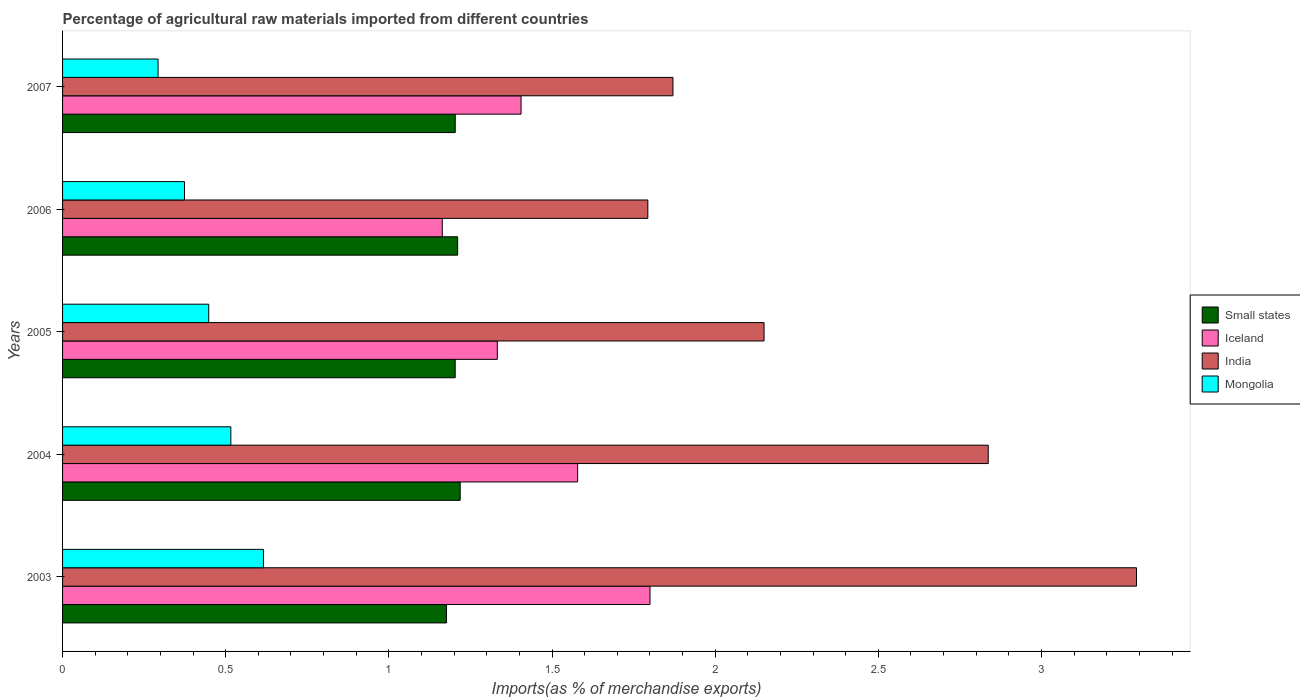How many different coloured bars are there?
Ensure brevity in your answer.  4. How many bars are there on the 5th tick from the bottom?
Your response must be concise. 4. What is the percentage of imports to different countries in Mongolia in 2004?
Give a very brief answer. 0.52. Across all years, what is the maximum percentage of imports to different countries in India?
Give a very brief answer. 3.29. Across all years, what is the minimum percentage of imports to different countries in Small states?
Offer a very short reply. 1.18. In which year was the percentage of imports to different countries in India minimum?
Make the answer very short. 2006. What is the total percentage of imports to different countries in India in the graph?
Offer a very short reply. 11.94. What is the difference between the percentage of imports to different countries in Small states in 2003 and that in 2004?
Ensure brevity in your answer.  -0.04. What is the difference between the percentage of imports to different countries in Small states in 2005 and the percentage of imports to different countries in India in 2003?
Offer a very short reply. -2.09. What is the average percentage of imports to different countries in Iceland per year?
Your response must be concise. 1.46. In the year 2006, what is the difference between the percentage of imports to different countries in Iceland and percentage of imports to different countries in India?
Provide a succinct answer. -0.63. What is the ratio of the percentage of imports to different countries in Small states in 2005 to that in 2006?
Ensure brevity in your answer.  0.99. What is the difference between the highest and the second highest percentage of imports to different countries in Mongolia?
Your answer should be compact. 0.1. What is the difference between the highest and the lowest percentage of imports to different countries in Small states?
Make the answer very short. 0.04. Is the sum of the percentage of imports to different countries in India in 2004 and 2007 greater than the maximum percentage of imports to different countries in Small states across all years?
Keep it short and to the point. Yes. Is it the case that in every year, the sum of the percentage of imports to different countries in Small states and percentage of imports to different countries in Iceland is greater than the sum of percentage of imports to different countries in India and percentage of imports to different countries in Mongolia?
Your answer should be compact. No. Is it the case that in every year, the sum of the percentage of imports to different countries in Mongolia and percentage of imports to different countries in Iceland is greater than the percentage of imports to different countries in Small states?
Your response must be concise. Yes. How many bars are there?
Offer a very short reply. 20. Are the values on the major ticks of X-axis written in scientific E-notation?
Make the answer very short. No. Does the graph contain any zero values?
Provide a short and direct response. No. Does the graph contain grids?
Provide a short and direct response. No. Where does the legend appear in the graph?
Ensure brevity in your answer.  Center right. What is the title of the graph?
Provide a succinct answer. Percentage of agricultural raw materials imported from different countries. Does "Sudan" appear as one of the legend labels in the graph?
Make the answer very short. No. What is the label or title of the X-axis?
Your answer should be compact. Imports(as % of merchandise exports). What is the label or title of the Y-axis?
Offer a very short reply. Years. What is the Imports(as % of merchandise exports) of Small states in 2003?
Provide a succinct answer. 1.18. What is the Imports(as % of merchandise exports) of Iceland in 2003?
Your answer should be compact. 1.8. What is the Imports(as % of merchandise exports) in India in 2003?
Your answer should be very brief. 3.29. What is the Imports(as % of merchandise exports) of Mongolia in 2003?
Your answer should be very brief. 0.62. What is the Imports(as % of merchandise exports) of Small states in 2004?
Ensure brevity in your answer.  1.22. What is the Imports(as % of merchandise exports) in Iceland in 2004?
Make the answer very short. 1.58. What is the Imports(as % of merchandise exports) of India in 2004?
Your answer should be very brief. 2.84. What is the Imports(as % of merchandise exports) of Mongolia in 2004?
Provide a succinct answer. 0.52. What is the Imports(as % of merchandise exports) in Small states in 2005?
Your answer should be very brief. 1.2. What is the Imports(as % of merchandise exports) of Iceland in 2005?
Offer a very short reply. 1.33. What is the Imports(as % of merchandise exports) in India in 2005?
Your answer should be compact. 2.15. What is the Imports(as % of merchandise exports) of Mongolia in 2005?
Ensure brevity in your answer.  0.45. What is the Imports(as % of merchandise exports) of Small states in 2006?
Give a very brief answer. 1.21. What is the Imports(as % of merchandise exports) in Iceland in 2006?
Ensure brevity in your answer.  1.16. What is the Imports(as % of merchandise exports) of India in 2006?
Your response must be concise. 1.79. What is the Imports(as % of merchandise exports) in Mongolia in 2006?
Keep it short and to the point. 0.37. What is the Imports(as % of merchandise exports) of Small states in 2007?
Provide a succinct answer. 1.2. What is the Imports(as % of merchandise exports) of Iceland in 2007?
Provide a succinct answer. 1.41. What is the Imports(as % of merchandise exports) in India in 2007?
Your answer should be compact. 1.87. What is the Imports(as % of merchandise exports) in Mongolia in 2007?
Give a very brief answer. 0.29. Across all years, what is the maximum Imports(as % of merchandise exports) of Small states?
Ensure brevity in your answer.  1.22. Across all years, what is the maximum Imports(as % of merchandise exports) in Iceland?
Provide a succinct answer. 1.8. Across all years, what is the maximum Imports(as % of merchandise exports) in India?
Give a very brief answer. 3.29. Across all years, what is the maximum Imports(as % of merchandise exports) in Mongolia?
Give a very brief answer. 0.62. Across all years, what is the minimum Imports(as % of merchandise exports) in Small states?
Your response must be concise. 1.18. Across all years, what is the minimum Imports(as % of merchandise exports) of Iceland?
Your answer should be very brief. 1.16. Across all years, what is the minimum Imports(as % of merchandise exports) of India?
Give a very brief answer. 1.79. Across all years, what is the minimum Imports(as % of merchandise exports) in Mongolia?
Keep it short and to the point. 0.29. What is the total Imports(as % of merchandise exports) of Small states in the graph?
Your answer should be very brief. 6.01. What is the total Imports(as % of merchandise exports) in Iceland in the graph?
Provide a succinct answer. 7.28. What is the total Imports(as % of merchandise exports) of India in the graph?
Offer a very short reply. 11.94. What is the total Imports(as % of merchandise exports) of Mongolia in the graph?
Offer a very short reply. 2.25. What is the difference between the Imports(as % of merchandise exports) of Small states in 2003 and that in 2004?
Offer a very short reply. -0.04. What is the difference between the Imports(as % of merchandise exports) of Iceland in 2003 and that in 2004?
Keep it short and to the point. 0.22. What is the difference between the Imports(as % of merchandise exports) in India in 2003 and that in 2004?
Provide a short and direct response. 0.45. What is the difference between the Imports(as % of merchandise exports) of Mongolia in 2003 and that in 2004?
Make the answer very short. 0.1. What is the difference between the Imports(as % of merchandise exports) of Small states in 2003 and that in 2005?
Keep it short and to the point. -0.03. What is the difference between the Imports(as % of merchandise exports) in Iceland in 2003 and that in 2005?
Your answer should be compact. 0.47. What is the difference between the Imports(as % of merchandise exports) of India in 2003 and that in 2005?
Offer a terse response. 1.14. What is the difference between the Imports(as % of merchandise exports) of Mongolia in 2003 and that in 2005?
Provide a short and direct response. 0.17. What is the difference between the Imports(as % of merchandise exports) in Small states in 2003 and that in 2006?
Offer a terse response. -0.03. What is the difference between the Imports(as % of merchandise exports) in Iceland in 2003 and that in 2006?
Offer a very short reply. 0.64. What is the difference between the Imports(as % of merchandise exports) in India in 2003 and that in 2006?
Your answer should be very brief. 1.5. What is the difference between the Imports(as % of merchandise exports) in Mongolia in 2003 and that in 2006?
Your response must be concise. 0.24. What is the difference between the Imports(as % of merchandise exports) of Small states in 2003 and that in 2007?
Your response must be concise. -0.03. What is the difference between the Imports(as % of merchandise exports) in Iceland in 2003 and that in 2007?
Give a very brief answer. 0.4. What is the difference between the Imports(as % of merchandise exports) of India in 2003 and that in 2007?
Give a very brief answer. 1.42. What is the difference between the Imports(as % of merchandise exports) in Mongolia in 2003 and that in 2007?
Provide a succinct answer. 0.32. What is the difference between the Imports(as % of merchandise exports) in Small states in 2004 and that in 2005?
Your answer should be compact. 0.02. What is the difference between the Imports(as % of merchandise exports) of Iceland in 2004 and that in 2005?
Offer a very short reply. 0.25. What is the difference between the Imports(as % of merchandise exports) of India in 2004 and that in 2005?
Your answer should be very brief. 0.69. What is the difference between the Imports(as % of merchandise exports) in Mongolia in 2004 and that in 2005?
Give a very brief answer. 0.07. What is the difference between the Imports(as % of merchandise exports) of Small states in 2004 and that in 2006?
Keep it short and to the point. 0.01. What is the difference between the Imports(as % of merchandise exports) of Iceland in 2004 and that in 2006?
Your response must be concise. 0.41. What is the difference between the Imports(as % of merchandise exports) of India in 2004 and that in 2006?
Offer a terse response. 1.04. What is the difference between the Imports(as % of merchandise exports) of Mongolia in 2004 and that in 2006?
Offer a very short reply. 0.14. What is the difference between the Imports(as % of merchandise exports) in Small states in 2004 and that in 2007?
Offer a terse response. 0.02. What is the difference between the Imports(as % of merchandise exports) of Iceland in 2004 and that in 2007?
Offer a very short reply. 0.17. What is the difference between the Imports(as % of merchandise exports) in India in 2004 and that in 2007?
Your answer should be very brief. 0.97. What is the difference between the Imports(as % of merchandise exports) in Mongolia in 2004 and that in 2007?
Give a very brief answer. 0.22. What is the difference between the Imports(as % of merchandise exports) in Small states in 2005 and that in 2006?
Offer a terse response. -0.01. What is the difference between the Imports(as % of merchandise exports) of Iceland in 2005 and that in 2006?
Provide a succinct answer. 0.17. What is the difference between the Imports(as % of merchandise exports) in India in 2005 and that in 2006?
Provide a short and direct response. 0.36. What is the difference between the Imports(as % of merchandise exports) of Mongolia in 2005 and that in 2006?
Ensure brevity in your answer.  0.07. What is the difference between the Imports(as % of merchandise exports) in Small states in 2005 and that in 2007?
Your response must be concise. -0. What is the difference between the Imports(as % of merchandise exports) of Iceland in 2005 and that in 2007?
Provide a short and direct response. -0.07. What is the difference between the Imports(as % of merchandise exports) of India in 2005 and that in 2007?
Offer a terse response. 0.28. What is the difference between the Imports(as % of merchandise exports) in Mongolia in 2005 and that in 2007?
Ensure brevity in your answer.  0.16. What is the difference between the Imports(as % of merchandise exports) of Small states in 2006 and that in 2007?
Provide a short and direct response. 0.01. What is the difference between the Imports(as % of merchandise exports) of Iceland in 2006 and that in 2007?
Your answer should be compact. -0.24. What is the difference between the Imports(as % of merchandise exports) of India in 2006 and that in 2007?
Provide a short and direct response. -0.08. What is the difference between the Imports(as % of merchandise exports) in Mongolia in 2006 and that in 2007?
Your answer should be very brief. 0.08. What is the difference between the Imports(as % of merchandise exports) of Small states in 2003 and the Imports(as % of merchandise exports) of Iceland in 2004?
Keep it short and to the point. -0.4. What is the difference between the Imports(as % of merchandise exports) of Small states in 2003 and the Imports(as % of merchandise exports) of India in 2004?
Offer a very short reply. -1.66. What is the difference between the Imports(as % of merchandise exports) in Small states in 2003 and the Imports(as % of merchandise exports) in Mongolia in 2004?
Offer a terse response. 0.66. What is the difference between the Imports(as % of merchandise exports) in Iceland in 2003 and the Imports(as % of merchandise exports) in India in 2004?
Provide a short and direct response. -1.04. What is the difference between the Imports(as % of merchandise exports) in Iceland in 2003 and the Imports(as % of merchandise exports) in Mongolia in 2004?
Offer a terse response. 1.28. What is the difference between the Imports(as % of merchandise exports) of India in 2003 and the Imports(as % of merchandise exports) of Mongolia in 2004?
Your answer should be compact. 2.78. What is the difference between the Imports(as % of merchandise exports) in Small states in 2003 and the Imports(as % of merchandise exports) in Iceland in 2005?
Your answer should be very brief. -0.16. What is the difference between the Imports(as % of merchandise exports) of Small states in 2003 and the Imports(as % of merchandise exports) of India in 2005?
Give a very brief answer. -0.97. What is the difference between the Imports(as % of merchandise exports) in Small states in 2003 and the Imports(as % of merchandise exports) in Mongolia in 2005?
Ensure brevity in your answer.  0.73. What is the difference between the Imports(as % of merchandise exports) of Iceland in 2003 and the Imports(as % of merchandise exports) of India in 2005?
Your answer should be very brief. -0.35. What is the difference between the Imports(as % of merchandise exports) of Iceland in 2003 and the Imports(as % of merchandise exports) of Mongolia in 2005?
Provide a succinct answer. 1.35. What is the difference between the Imports(as % of merchandise exports) in India in 2003 and the Imports(as % of merchandise exports) in Mongolia in 2005?
Ensure brevity in your answer.  2.84. What is the difference between the Imports(as % of merchandise exports) of Small states in 2003 and the Imports(as % of merchandise exports) of Iceland in 2006?
Ensure brevity in your answer.  0.01. What is the difference between the Imports(as % of merchandise exports) of Small states in 2003 and the Imports(as % of merchandise exports) of India in 2006?
Offer a terse response. -0.62. What is the difference between the Imports(as % of merchandise exports) in Small states in 2003 and the Imports(as % of merchandise exports) in Mongolia in 2006?
Your answer should be very brief. 0.8. What is the difference between the Imports(as % of merchandise exports) in Iceland in 2003 and the Imports(as % of merchandise exports) in India in 2006?
Provide a succinct answer. 0.01. What is the difference between the Imports(as % of merchandise exports) in Iceland in 2003 and the Imports(as % of merchandise exports) in Mongolia in 2006?
Keep it short and to the point. 1.43. What is the difference between the Imports(as % of merchandise exports) in India in 2003 and the Imports(as % of merchandise exports) in Mongolia in 2006?
Provide a succinct answer. 2.92. What is the difference between the Imports(as % of merchandise exports) in Small states in 2003 and the Imports(as % of merchandise exports) in Iceland in 2007?
Your response must be concise. -0.23. What is the difference between the Imports(as % of merchandise exports) of Small states in 2003 and the Imports(as % of merchandise exports) of India in 2007?
Keep it short and to the point. -0.69. What is the difference between the Imports(as % of merchandise exports) in Small states in 2003 and the Imports(as % of merchandise exports) in Mongolia in 2007?
Offer a very short reply. 0.88. What is the difference between the Imports(as % of merchandise exports) in Iceland in 2003 and the Imports(as % of merchandise exports) in India in 2007?
Your answer should be compact. -0.07. What is the difference between the Imports(as % of merchandise exports) in Iceland in 2003 and the Imports(as % of merchandise exports) in Mongolia in 2007?
Offer a terse response. 1.51. What is the difference between the Imports(as % of merchandise exports) of India in 2003 and the Imports(as % of merchandise exports) of Mongolia in 2007?
Your answer should be very brief. 3. What is the difference between the Imports(as % of merchandise exports) of Small states in 2004 and the Imports(as % of merchandise exports) of Iceland in 2005?
Offer a terse response. -0.11. What is the difference between the Imports(as % of merchandise exports) of Small states in 2004 and the Imports(as % of merchandise exports) of India in 2005?
Provide a succinct answer. -0.93. What is the difference between the Imports(as % of merchandise exports) in Small states in 2004 and the Imports(as % of merchandise exports) in Mongolia in 2005?
Make the answer very short. 0.77. What is the difference between the Imports(as % of merchandise exports) of Iceland in 2004 and the Imports(as % of merchandise exports) of India in 2005?
Offer a terse response. -0.57. What is the difference between the Imports(as % of merchandise exports) in Iceland in 2004 and the Imports(as % of merchandise exports) in Mongolia in 2005?
Offer a terse response. 1.13. What is the difference between the Imports(as % of merchandise exports) in India in 2004 and the Imports(as % of merchandise exports) in Mongolia in 2005?
Provide a succinct answer. 2.39. What is the difference between the Imports(as % of merchandise exports) of Small states in 2004 and the Imports(as % of merchandise exports) of Iceland in 2006?
Ensure brevity in your answer.  0.05. What is the difference between the Imports(as % of merchandise exports) in Small states in 2004 and the Imports(as % of merchandise exports) in India in 2006?
Ensure brevity in your answer.  -0.57. What is the difference between the Imports(as % of merchandise exports) in Small states in 2004 and the Imports(as % of merchandise exports) in Mongolia in 2006?
Keep it short and to the point. 0.84. What is the difference between the Imports(as % of merchandise exports) of Iceland in 2004 and the Imports(as % of merchandise exports) of India in 2006?
Provide a succinct answer. -0.22. What is the difference between the Imports(as % of merchandise exports) in Iceland in 2004 and the Imports(as % of merchandise exports) in Mongolia in 2006?
Provide a short and direct response. 1.2. What is the difference between the Imports(as % of merchandise exports) in India in 2004 and the Imports(as % of merchandise exports) in Mongolia in 2006?
Ensure brevity in your answer.  2.46. What is the difference between the Imports(as % of merchandise exports) of Small states in 2004 and the Imports(as % of merchandise exports) of Iceland in 2007?
Give a very brief answer. -0.19. What is the difference between the Imports(as % of merchandise exports) in Small states in 2004 and the Imports(as % of merchandise exports) in India in 2007?
Your response must be concise. -0.65. What is the difference between the Imports(as % of merchandise exports) in Small states in 2004 and the Imports(as % of merchandise exports) in Mongolia in 2007?
Your response must be concise. 0.93. What is the difference between the Imports(as % of merchandise exports) of Iceland in 2004 and the Imports(as % of merchandise exports) of India in 2007?
Offer a terse response. -0.29. What is the difference between the Imports(as % of merchandise exports) of Iceland in 2004 and the Imports(as % of merchandise exports) of Mongolia in 2007?
Provide a succinct answer. 1.29. What is the difference between the Imports(as % of merchandise exports) in India in 2004 and the Imports(as % of merchandise exports) in Mongolia in 2007?
Your answer should be compact. 2.54. What is the difference between the Imports(as % of merchandise exports) of Small states in 2005 and the Imports(as % of merchandise exports) of Iceland in 2006?
Offer a very short reply. 0.04. What is the difference between the Imports(as % of merchandise exports) in Small states in 2005 and the Imports(as % of merchandise exports) in India in 2006?
Make the answer very short. -0.59. What is the difference between the Imports(as % of merchandise exports) of Small states in 2005 and the Imports(as % of merchandise exports) of Mongolia in 2006?
Provide a succinct answer. 0.83. What is the difference between the Imports(as % of merchandise exports) of Iceland in 2005 and the Imports(as % of merchandise exports) of India in 2006?
Provide a succinct answer. -0.46. What is the difference between the Imports(as % of merchandise exports) of Iceland in 2005 and the Imports(as % of merchandise exports) of Mongolia in 2006?
Provide a short and direct response. 0.96. What is the difference between the Imports(as % of merchandise exports) of India in 2005 and the Imports(as % of merchandise exports) of Mongolia in 2006?
Give a very brief answer. 1.78. What is the difference between the Imports(as % of merchandise exports) in Small states in 2005 and the Imports(as % of merchandise exports) in Iceland in 2007?
Offer a terse response. -0.2. What is the difference between the Imports(as % of merchandise exports) in Small states in 2005 and the Imports(as % of merchandise exports) in India in 2007?
Your answer should be very brief. -0.67. What is the difference between the Imports(as % of merchandise exports) in Small states in 2005 and the Imports(as % of merchandise exports) in Mongolia in 2007?
Offer a very short reply. 0.91. What is the difference between the Imports(as % of merchandise exports) of Iceland in 2005 and the Imports(as % of merchandise exports) of India in 2007?
Provide a short and direct response. -0.54. What is the difference between the Imports(as % of merchandise exports) of Iceland in 2005 and the Imports(as % of merchandise exports) of Mongolia in 2007?
Offer a terse response. 1.04. What is the difference between the Imports(as % of merchandise exports) in India in 2005 and the Imports(as % of merchandise exports) in Mongolia in 2007?
Give a very brief answer. 1.86. What is the difference between the Imports(as % of merchandise exports) in Small states in 2006 and the Imports(as % of merchandise exports) in Iceland in 2007?
Your response must be concise. -0.19. What is the difference between the Imports(as % of merchandise exports) of Small states in 2006 and the Imports(as % of merchandise exports) of India in 2007?
Offer a terse response. -0.66. What is the difference between the Imports(as % of merchandise exports) of Small states in 2006 and the Imports(as % of merchandise exports) of Mongolia in 2007?
Ensure brevity in your answer.  0.92. What is the difference between the Imports(as % of merchandise exports) in Iceland in 2006 and the Imports(as % of merchandise exports) in India in 2007?
Make the answer very short. -0.71. What is the difference between the Imports(as % of merchandise exports) of Iceland in 2006 and the Imports(as % of merchandise exports) of Mongolia in 2007?
Offer a very short reply. 0.87. What is the difference between the Imports(as % of merchandise exports) of India in 2006 and the Imports(as % of merchandise exports) of Mongolia in 2007?
Keep it short and to the point. 1.5. What is the average Imports(as % of merchandise exports) in Small states per year?
Offer a terse response. 1.2. What is the average Imports(as % of merchandise exports) of Iceland per year?
Provide a short and direct response. 1.46. What is the average Imports(as % of merchandise exports) in India per year?
Offer a terse response. 2.39. What is the average Imports(as % of merchandise exports) of Mongolia per year?
Give a very brief answer. 0.45. In the year 2003, what is the difference between the Imports(as % of merchandise exports) in Small states and Imports(as % of merchandise exports) in Iceland?
Make the answer very short. -0.62. In the year 2003, what is the difference between the Imports(as % of merchandise exports) in Small states and Imports(as % of merchandise exports) in India?
Your response must be concise. -2.11. In the year 2003, what is the difference between the Imports(as % of merchandise exports) in Small states and Imports(as % of merchandise exports) in Mongolia?
Your response must be concise. 0.56. In the year 2003, what is the difference between the Imports(as % of merchandise exports) of Iceland and Imports(as % of merchandise exports) of India?
Offer a terse response. -1.49. In the year 2003, what is the difference between the Imports(as % of merchandise exports) in Iceland and Imports(as % of merchandise exports) in Mongolia?
Provide a succinct answer. 1.18. In the year 2003, what is the difference between the Imports(as % of merchandise exports) in India and Imports(as % of merchandise exports) in Mongolia?
Your answer should be very brief. 2.68. In the year 2004, what is the difference between the Imports(as % of merchandise exports) of Small states and Imports(as % of merchandise exports) of Iceland?
Keep it short and to the point. -0.36. In the year 2004, what is the difference between the Imports(as % of merchandise exports) in Small states and Imports(as % of merchandise exports) in India?
Your answer should be compact. -1.62. In the year 2004, what is the difference between the Imports(as % of merchandise exports) in Small states and Imports(as % of merchandise exports) in Mongolia?
Offer a terse response. 0.7. In the year 2004, what is the difference between the Imports(as % of merchandise exports) of Iceland and Imports(as % of merchandise exports) of India?
Keep it short and to the point. -1.26. In the year 2004, what is the difference between the Imports(as % of merchandise exports) in Iceland and Imports(as % of merchandise exports) in Mongolia?
Offer a terse response. 1.06. In the year 2004, what is the difference between the Imports(as % of merchandise exports) in India and Imports(as % of merchandise exports) in Mongolia?
Your response must be concise. 2.32. In the year 2005, what is the difference between the Imports(as % of merchandise exports) of Small states and Imports(as % of merchandise exports) of Iceland?
Keep it short and to the point. -0.13. In the year 2005, what is the difference between the Imports(as % of merchandise exports) in Small states and Imports(as % of merchandise exports) in India?
Provide a succinct answer. -0.95. In the year 2005, what is the difference between the Imports(as % of merchandise exports) of Small states and Imports(as % of merchandise exports) of Mongolia?
Give a very brief answer. 0.76. In the year 2005, what is the difference between the Imports(as % of merchandise exports) in Iceland and Imports(as % of merchandise exports) in India?
Offer a very short reply. -0.82. In the year 2005, what is the difference between the Imports(as % of merchandise exports) in Iceland and Imports(as % of merchandise exports) in Mongolia?
Ensure brevity in your answer.  0.88. In the year 2005, what is the difference between the Imports(as % of merchandise exports) in India and Imports(as % of merchandise exports) in Mongolia?
Your response must be concise. 1.7. In the year 2006, what is the difference between the Imports(as % of merchandise exports) of Small states and Imports(as % of merchandise exports) of Iceland?
Your answer should be compact. 0.05. In the year 2006, what is the difference between the Imports(as % of merchandise exports) in Small states and Imports(as % of merchandise exports) in India?
Make the answer very short. -0.58. In the year 2006, what is the difference between the Imports(as % of merchandise exports) of Small states and Imports(as % of merchandise exports) of Mongolia?
Provide a succinct answer. 0.84. In the year 2006, what is the difference between the Imports(as % of merchandise exports) in Iceland and Imports(as % of merchandise exports) in India?
Provide a short and direct response. -0.63. In the year 2006, what is the difference between the Imports(as % of merchandise exports) of Iceland and Imports(as % of merchandise exports) of Mongolia?
Offer a very short reply. 0.79. In the year 2006, what is the difference between the Imports(as % of merchandise exports) of India and Imports(as % of merchandise exports) of Mongolia?
Offer a terse response. 1.42. In the year 2007, what is the difference between the Imports(as % of merchandise exports) in Small states and Imports(as % of merchandise exports) in Iceland?
Provide a short and direct response. -0.2. In the year 2007, what is the difference between the Imports(as % of merchandise exports) of Small states and Imports(as % of merchandise exports) of India?
Your answer should be compact. -0.67. In the year 2007, what is the difference between the Imports(as % of merchandise exports) of Small states and Imports(as % of merchandise exports) of Mongolia?
Give a very brief answer. 0.91. In the year 2007, what is the difference between the Imports(as % of merchandise exports) of Iceland and Imports(as % of merchandise exports) of India?
Offer a terse response. -0.47. In the year 2007, what is the difference between the Imports(as % of merchandise exports) of Iceland and Imports(as % of merchandise exports) of Mongolia?
Offer a terse response. 1.11. In the year 2007, what is the difference between the Imports(as % of merchandise exports) of India and Imports(as % of merchandise exports) of Mongolia?
Keep it short and to the point. 1.58. What is the ratio of the Imports(as % of merchandise exports) in Small states in 2003 to that in 2004?
Offer a very short reply. 0.97. What is the ratio of the Imports(as % of merchandise exports) of Iceland in 2003 to that in 2004?
Make the answer very short. 1.14. What is the ratio of the Imports(as % of merchandise exports) in India in 2003 to that in 2004?
Offer a terse response. 1.16. What is the ratio of the Imports(as % of merchandise exports) of Mongolia in 2003 to that in 2004?
Give a very brief answer. 1.19. What is the ratio of the Imports(as % of merchandise exports) in Small states in 2003 to that in 2005?
Ensure brevity in your answer.  0.98. What is the ratio of the Imports(as % of merchandise exports) of Iceland in 2003 to that in 2005?
Your response must be concise. 1.35. What is the ratio of the Imports(as % of merchandise exports) of India in 2003 to that in 2005?
Give a very brief answer. 1.53. What is the ratio of the Imports(as % of merchandise exports) in Mongolia in 2003 to that in 2005?
Offer a very short reply. 1.37. What is the ratio of the Imports(as % of merchandise exports) of Small states in 2003 to that in 2006?
Give a very brief answer. 0.97. What is the ratio of the Imports(as % of merchandise exports) in Iceland in 2003 to that in 2006?
Make the answer very short. 1.55. What is the ratio of the Imports(as % of merchandise exports) of India in 2003 to that in 2006?
Ensure brevity in your answer.  1.83. What is the ratio of the Imports(as % of merchandise exports) of Mongolia in 2003 to that in 2006?
Offer a very short reply. 1.65. What is the ratio of the Imports(as % of merchandise exports) of Small states in 2003 to that in 2007?
Your response must be concise. 0.98. What is the ratio of the Imports(as % of merchandise exports) in Iceland in 2003 to that in 2007?
Your response must be concise. 1.28. What is the ratio of the Imports(as % of merchandise exports) of India in 2003 to that in 2007?
Ensure brevity in your answer.  1.76. What is the ratio of the Imports(as % of merchandise exports) of Mongolia in 2003 to that in 2007?
Your response must be concise. 2.1. What is the ratio of the Imports(as % of merchandise exports) in Small states in 2004 to that in 2005?
Provide a succinct answer. 1.01. What is the ratio of the Imports(as % of merchandise exports) of Iceland in 2004 to that in 2005?
Your answer should be compact. 1.18. What is the ratio of the Imports(as % of merchandise exports) of India in 2004 to that in 2005?
Provide a succinct answer. 1.32. What is the ratio of the Imports(as % of merchandise exports) in Mongolia in 2004 to that in 2005?
Provide a succinct answer. 1.15. What is the ratio of the Imports(as % of merchandise exports) in Small states in 2004 to that in 2006?
Make the answer very short. 1.01. What is the ratio of the Imports(as % of merchandise exports) in Iceland in 2004 to that in 2006?
Provide a short and direct response. 1.36. What is the ratio of the Imports(as % of merchandise exports) in India in 2004 to that in 2006?
Keep it short and to the point. 1.58. What is the ratio of the Imports(as % of merchandise exports) in Mongolia in 2004 to that in 2006?
Give a very brief answer. 1.38. What is the ratio of the Imports(as % of merchandise exports) of Small states in 2004 to that in 2007?
Offer a very short reply. 1.01. What is the ratio of the Imports(as % of merchandise exports) in Iceland in 2004 to that in 2007?
Ensure brevity in your answer.  1.12. What is the ratio of the Imports(as % of merchandise exports) in India in 2004 to that in 2007?
Your response must be concise. 1.52. What is the ratio of the Imports(as % of merchandise exports) of Mongolia in 2004 to that in 2007?
Provide a succinct answer. 1.76. What is the ratio of the Imports(as % of merchandise exports) in Iceland in 2005 to that in 2006?
Your answer should be compact. 1.14. What is the ratio of the Imports(as % of merchandise exports) of India in 2005 to that in 2006?
Give a very brief answer. 1.2. What is the ratio of the Imports(as % of merchandise exports) of Mongolia in 2005 to that in 2006?
Offer a terse response. 1.2. What is the ratio of the Imports(as % of merchandise exports) in Iceland in 2005 to that in 2007?
Provide a succinct answer. 0.95. What is the ratio of the Imports(as % of merchandise exports) in India in 2005 to that in 2007?
Offer a very short reply. 1.15. What is the ratio of the Imports(as % of merchandise exports) of Mongolia in 2005 to that in 2007?
Keep it short and to the point. 1.53. What is the ratio of the Imports(as % of merchandise exports) of Small states in 2006 to that in 2007?
Your answer should be very brief. 1.01. What is the ratio of the Imports(as % of merchandise exports) of Iceland in 2006 to that in 2007?
Offer a very short reply. 0.83. What is the ratio of the Imports(as % of merchandise exports) of India in 2006 to that in 2007?
Provide a short and direct response. 0.96. What is the ratio of the Imports(as % of merchandise exports) of Mongolia in 2006 to that in 2007?
Keep it short and to the point. 1.28. What is the difference between the highest and the second highest Imports(as % of merchandise exports) of Small states?
Your response must be concise. 0.01. What is the difference between the highest and the second highest Imports(as % of merchandise exports) in Iceland?
Keep it short and to the point. 0.22. What is the difference between the highest and the second highest Imports(as % of merchandise exports) of India?
Your response must be concise. 0.45. What is the difference between the highest and the second highest Imports(as % of merchandise exports) of Mongolia?
Provide a short and direct response. 0.1. What is the difference between the highest and the lowest Imports(as % of merchandise exports) of Small states?
Provide a short and direct response. 0.04. What is the difference between the highest and the lowest Imports(as % of merchandise exports) in Iceland?
Make the answer very short. 0.64. What is the difference between the highest and the lowest Imports(as % of merchandise exports) in India?
Make the answer very short. 1.5. What is the difference between the highest and the lowest Imports(as % of merchandise exports) of Mongolia?
Keep it short and to the point. 0.32. 